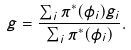Convert formula to latex. <formula><loc_0><loc_0><loc_500><loc_500>g = \frac { \sum _ { i } \pi ^ { * } ( \phi _ { i } ) g _ { i } } { \sum _ { i } \pi ^ { * } ( \phi _ { i } ) } .</formula> 